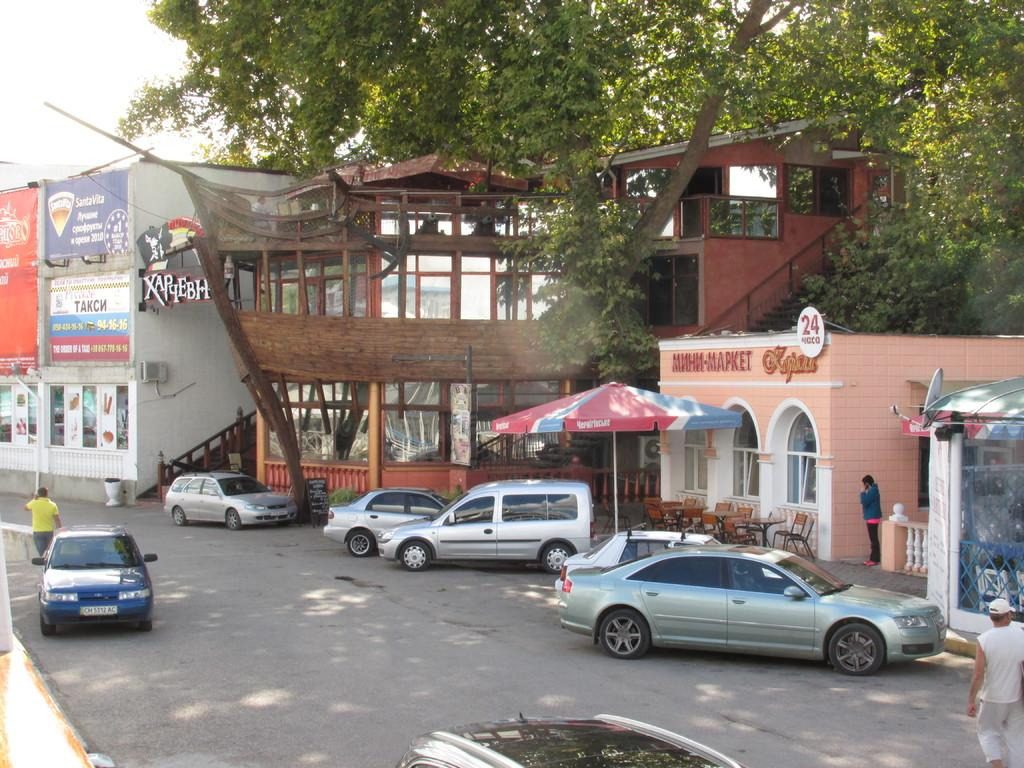What is located in the center of the image? There are buildings in the center of the image. What can be seen at the bottom side of the image? There are cars at the bottom side of the image. What type of vegetation is at the top side of the image? There are trees at the top side of the image. What type of cloth is draped over the trees in the image? There is no cloth draped over the trees in the image; only trees are present. How many books can be seen stacked next to the cars in the image? There are no books visible in the image; only cars are present. 